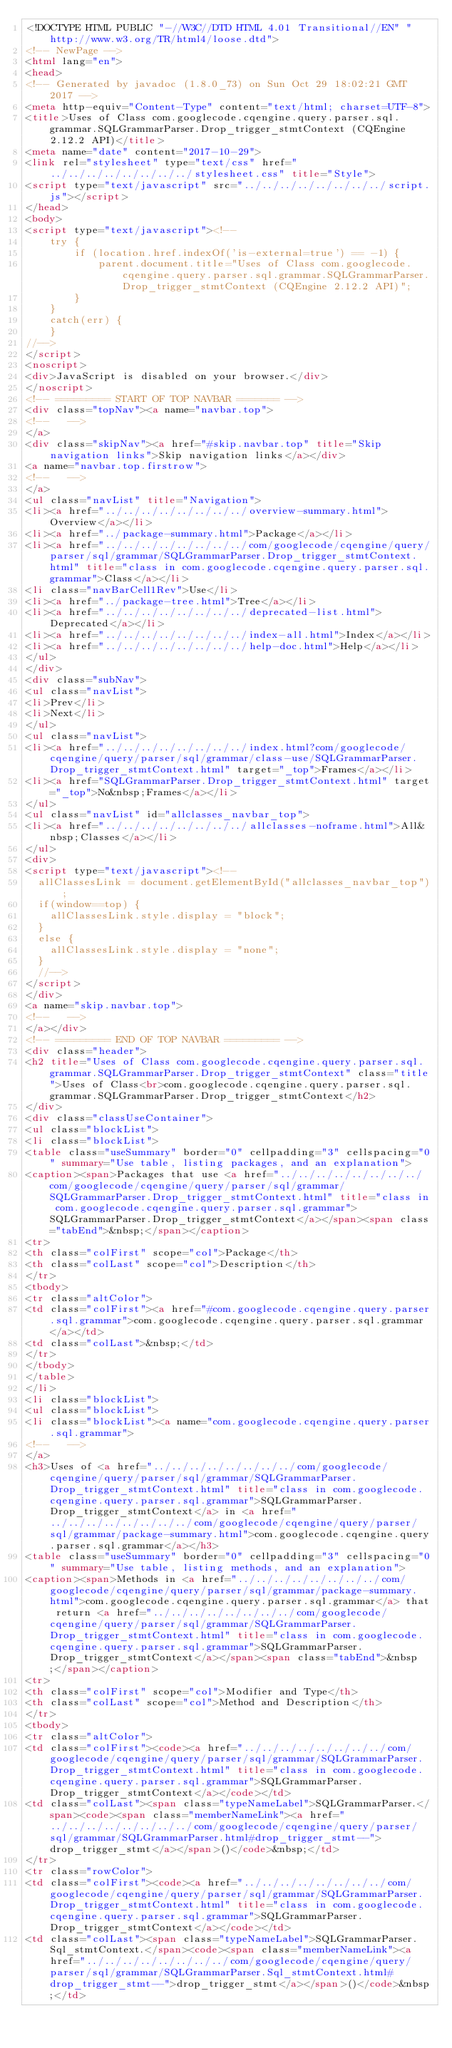<code> <loc_0><loc_0><loc_500><loc_500><_HTML_><!DOCTYPE HTML PUBLIC "-//W3C//DTD HTML 4.01 Transitional//EN" "http://www.w3.org/TR/html4/loose.dtd">
<!-- NewPage -->
<html lang="en">
<head>
<!-- Generated by javadoc (1.8.0_73) on Sun Oct 29 18:02:21 GMT 2017 -->
<meta http-equiv="Content-Type" content="text/html; charset=UTF-8">
<title>Uses of Class com.googlecode.cqengine.query.parser.sql.grammar.SQLGrammarParser.Drop_trigger_stmtContext (CQEngine 2.12.2 API)</title>
<meta name="date" content="2017-10-29">
<link rel="stylesheet" type="text/css" href="../../../../../../../../stylesheet.css" title="Style">
<script type="text/javascript" src="../../../../../../../../script.js"></script>
</head>
<body>
<script type="text/javascript"><!--
    try {
        if (location.href.indexOf('is-external=true') == -1) {
            parent.document.title="Uses of Class com.googlecode.cqengine.query.parser.sql.grammar.SQLGrammarParser.Drop_trigger_stmtContext (CQEngine 2.12.2 API)";
        }
    }
    catch(err) {
    }
//-->
</script>
<noscript>
<div>JavaScript is disabled on your browser.</div>
</noscript>
<!-- ========= START OF TOP NAVBAR ======= -->
<div class="topNav"><a name="navbar.top">
<!--   -->
</a>
<div class="skipNav"><a href="#skip.navbar.top" title="Skip navigation links">Skip navigation links</a></div>
<a name="navbar.top.firstrow">
<!--   -->
</a>
<ul class="navList" title="Navigation">
<li><a href="../../../../../../../../overview-summary.html">Overview</a></li>
<li><a href="../package-summary.html">Package</a></li>
<li><a href="../../../../../../../../com/googlecode/cqengine/query/parser/sql/grammar/SQLGrammarParser.Drop_trigger_stmtContext.html" title="class in com.googlecode.cqengine.query.parser.sql.grammar">Class</a></li>
<li class="navBarCell1Rev">Use</li>
<li><a href="../package-tree.html">Tree</a></li>
<li><a href="../../../../../../../../deprecated-list.html">Deprecated</a></li>
<li><a href="../../../../../../../../index-all.html">Index</a></li>
<li><a href="../../../../../../../../help-doc.html">Help</a></li>
</ul>
</div>
<div class="subNav">
<ul class="navList">
<li>Prev</li>
<li>Next</li>
</ul>
<ul class="navList">
<li><a href="../../../../../../../../index.html?com/googlecode/cqengine/query/parser/sql/grammar/class-use/SQLGrammarParser.Drop_trigger_stmtContext.html" target="_top">Frames</a></li>
<li><a href="SQLGrammarParser.Drop_trigger_stmtContext.html" target="_top">No&nbsp;Frames</a></li>
</ul>
<ul class="navList" id="allclasses_navbar_top">
<li><a href="../../../../../../../../allclasses-noframe.html">All&nbsp;Classes</a></li>
</ul>
<div>
<script type="text/javascript"><!--
  allClassesLink = document.getElementById("allclasses_navbar_top");
  if(window==top) {
    allClassesLink.style.display = "block";
  }
  else {
    allClassesLink.style.display = "none";
  }
  //-->
</script>
</div>
<a name="skip.navbar.top">
<!--   -->
</a></div>
<!-- ========= END OF TOP NAVBAR ========= -->
<div class="header">
<h2 title="Uses of Class com.googlecode.cqengine.query.parser.sql.grammar.SQLGrammarParser.Drop_trigger_stmtContext" class="title">Uses of Class<br>com.googlecode.cqengine.query.parser.sql.grammar.SQLGrammarParser.Drop_trigger_stmtContext</h2>
</div>
<div class="classUseContainer">
<ul class="blockList">
<li class="blockList">
<table class="useSummary" border="0" cellpadding="3" cellspacing="0" summary="Use table, listing packages, and an explanation">
<caption><span>Packages that use <a href="../../../../../../../../com/googlecode/cqengine/query/parser/sql/grammar/SQLGrammarParser.Drop_trigger_stmtContext.html" title="class in com.googlecode.cqengine.query.parser.sql.grammar">SQLGrammarParser.Drop_trigger_stmtContext</a></span><span class="tabEnd">&nbsp;</span></caption>
<tr>
<th class="colFirst" scope="col">Package</th>
<th class="colLast" scope="col">Description</th>
</tr>
<tbody>
<tr class="altColor">
<td class="colFirst"><a href="#com.googlecode.cqengine.query.parser.sql.grammar">com.googlecode.cqengine.query.parser.sql.grammar</a></td>
<td class="colLast">&nbsp;</td>
</tr>
</tbody>
</table>
</li>
<li class="blockList">
<ul class="blockList">
<li class="blockList"><a name="com.googlecode.cqengine.query.parser.sql.grammar">
<!--   -->
</a>
<h3>Uses of <a href="../../../../../../../../com/googlecode/cqengine/query/parser/sql/grammar/SQLGrammarParser.Drop_trigger_stmtContext.html" title="class in com.googlecode.cqengine.query.parser.sql.grammar">SQLGrammarParser.Drop_trigger_stmtContext</a> in <a href="../../../../../../../../com/googlecode/cqengine/query/parser/sql/grammar/package-summary.html">com.googlecode.cqengine.query.parser.sql.grammar</a></h3>
<table class="useSummary" border="0" cellpadding="3" cellspacing="0" summary="Use table, listing methods, and an explanation">
<caption><span>Methods in <a href="../../../../../../../../com/googlecode/cqengine/query/parser/sql/grammar/package-summary.html">com.googlecode.cqengine.query.parser.sql.grammar</a> that return <a href="../../../../../../../../com/googlecode/cqengine/query/parser/sql/grammar/SQLGrammarParser.Drop_trigger_stmtContext.html" title="class in com.googlecode.cqengine.query.parser.sql.grammar">SQLGrammarParser.Drop_trigger_stmtContext</a></span><span class="tabEnd">&nbsp;</span></caption>
<tr>
<th class="colFirst" scope="col">Modifier and Type</th>
<th class="colLast" scope="col">Method and Description</th>
</tr>
<tbody>
<tr class="altColor">
<td class="colFirst"><code><a href="../../../../../../../../com/googlecode/cqengine/query/parser/sql/grammar/SQLGrammarParser.Drop_trigger_stmtContext.html" title="class in com.googlecode.cqengine.query.parser.sql.grammar">SQLGrammarParser.Drop_trigger_stmtContext</a></code></td>
<td class="colLast"><span class="typeNameLabel">SQLGrammarParser.</span><code><span class="memberNameLink"><a href="../../../../../../../../com/googlecode/cqengine/query/parser/sql/grammar/SQLGrammarParser.html#drop_trigger_stmt--">drop_trigger_stmt</a></span>()</code>&nbsp;</td>
</tr>
<tr class="rowColor">
<td class="colFirst"><code><a href="../../../../../../../../com/googlecode/cqengine/query/parser/sql/grammar/SQLGrammarParser.Drop_trigger_stmtContext.html" title="class in com.googlecode.cqengine.query.parser.sql.grammar">SQLGrammarParser.Drop_trigger_stmtContext</a></code></td>
<td class="colLast"><span class="typeNameLabel">SQLGrammarParser.Sql_stmtContext.</span><code><span class="memberNameLink"><a href="../../../../../../../../com/googlecode/cqengine/query/parser/sql/grammar/SQLGrammarParser.Sql_stmtContext.html#drop_trigger_stmt--">drop_trigger_stmt</a></span>()</code>&nbsp;</td></code> 